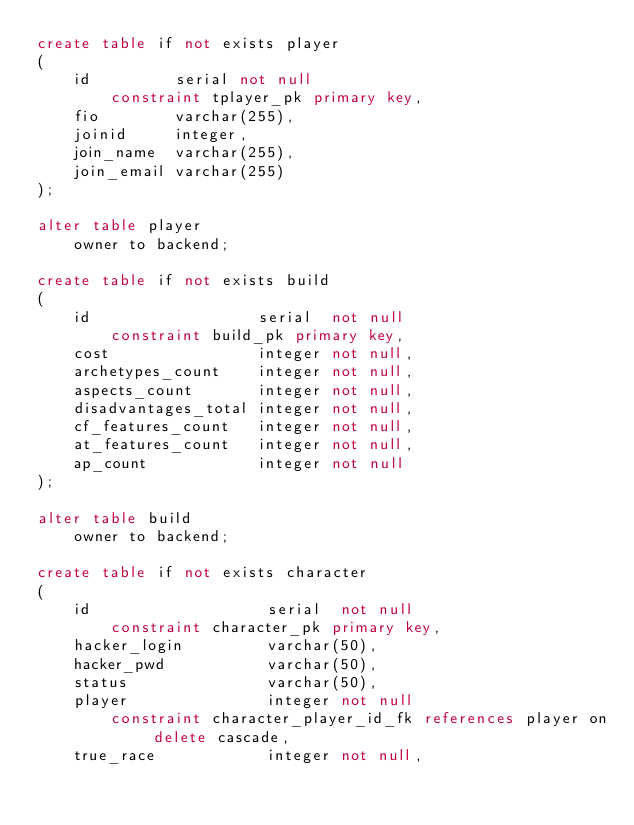<code> <loc_0><loc_0><loc_500><loc_500><_SQL_>create table if not exists player
(
    id         serial not null
        constraint tplayer_pk primary key,
    fio        varchar(255),
    joinid     integer,
    join_name  varchar(255),
    join_email varchar(255)
);

alter table player
    owner to backend;

create table if not exists build
(
    id                  serial  not null
        constraint build_pk primary key,
    cost                integer not null,
    archetypes_count    integer not null,
    aspects_count       integer not null,
    disadvantages_total integer not null,
    cf_features_count   integer not null,
    at_features_count   integer not null,
    ap_count            integer not null
);

alter table build
    owner to backend;

create table if not exists character
(
    id                   serial  not null
        constraint character_pk primary key,
    hacker_login         varchar(50),
    hacker_pwd           varchar(50),
    status               varchar(50),
    player               integer not null
        constraint character_player_id_fk references player on delete cascade,
    true_race            integer not null,</code> 